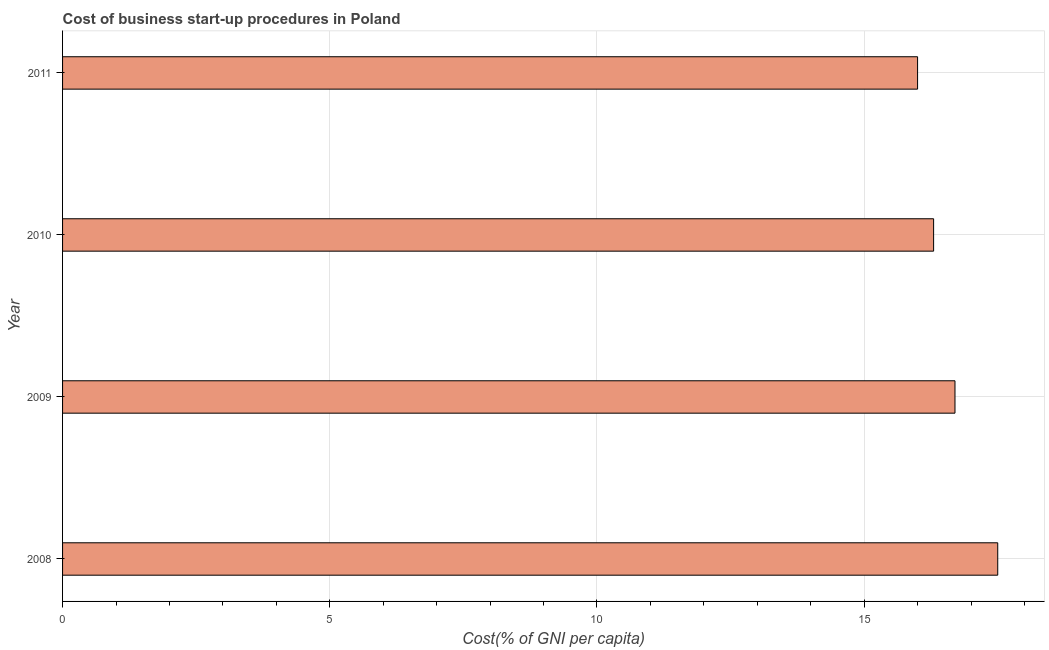What is the title of the graph?
Offer a terse response. Cost of business start-up procedures in Poland. What is the label or title of the X-axis?
Ensure brevity in your answer.  Cost(% of GNI per capita). What is the cost of business startup procedures in 2009?
Provide a succinct answer. 16.7. Across all years, what is the maximum cost of business startup procedures?
Offer a terse response. 17.5. In which year was the cost of business startup procedures maximum?
Your response must be concise. 2008. What is the sum of the cost of business startup procedures?
Keep it short and to the point. 66.5. What is the average cost of business startup procedures per year?
Your answer should be compact. 16.62. What is the median cost of business startup procedures?
Provide a short and direct response. 16.5. In how many years, is the cost of business startup procedures greater than 10 %?
Offer a terse response. 4. Do a majority of the years between 2008 and 2009 (inclusive) have cost of business startup procedures greater than 6 %?
Ensure brevity in your answer.  Yes. What is the ratio of the cost of business startup procedures in 2009 to that in 2011?
Offer a very short reply. 1.04. Is the difference between the cost of business startup procedures in 2009 and 2011 greater than the difference between any two years?
Offer a terse response. No. What is the difference between the highest and the second highest cost of business startup procedures?
Make the answer very short. 0.8. What is the difference between the highest and the lowest cost of business startup procedures?
Your answer should be compact. 1.5. In how many years, is the cost of business startup procedures greater than the average cost of business startup procedures taken over all years?
Keep it short and to the point. 2. How many bars are there?
Keep it short and to the point. 4. How many years are there in the graph?
Offer a very short reply. 4. What is the Cost(% of GNI per capita) in 2008?
Offer a terse response. 17.5. What is the Cost(% of GNI per capita) of 2009?
Provide a succinct answer. 16.7. What is the Cost(% of GNI per capita) of 2010?
Keep it short and to the point. 16.3. What is the Cost(% of GNI per capita) of 2011?
Offer a terse response. 16. What is the difference between the Cost(% of GNI per capita) in 2008 and 2009?
Ensure brevity in your answer.  0.8. What is the difference between the Cost(% of GNI per capita) in 2008 and 2010?
Your response must be concise. 1.2. What is the difference between the Cost(% of GNI per capita) in 2008 and 2011?
Offer a very short reply. 1.5. What is the difference between the Cost(% of GNI per capita) in 2009 and 2010?
Ensure brevity in your answer.  0.4. What is the ratio of the Cost(% of GNI per capita) in 2008 to that in 2009?
Offer a very short reply. 1.05. What is the ratio of the Cost(% of GNI per capita) in 2008 to that in 2010?
Your response must be concise. 1.07. What is the ratio of the Cost(% of GNI per capita) in 2008 to that in 2011?
Provide a short and direct response. 1.09. What is the ratio of the Cost(% of GNI per capita) in 2009 to that in 2011?
Keep it short and to the point. 1.04. 